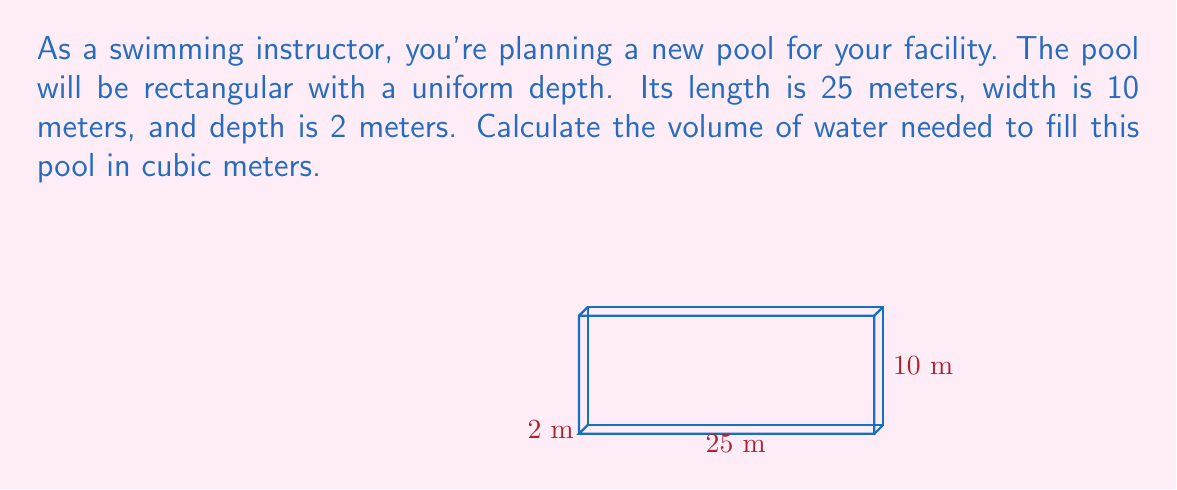Could you help me with this problem? To calculate the volume of a rectangular pool, we need to multiply its length, width, and depth.

Let's define our variables:
$l$ = length = 25 meters
$w$ = width = 10 meters
$d$ = depth = 2 meters

The formula for the volume of a rectangular prism is:

$$V = l \times w \times d$$

Substituting our values:

$$V = 25 \text{ m} \times 10 \text{ m} \times 2 \text{ m}$$

Now, let's perform the multiplication:

$$V = 500 \text{ m}^3$$

Therefore, the volume of the pool is 500 cubic meters.
Answer: $500 \text{ m}^3$ 